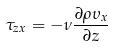Convert formula to latex. <formula><loc_0><loc_0><loc_500><loc_500>\tau _ { z x } = - \nu \frac { \partial \rho \upsilon _ { x } } { \partial z }</formula> 